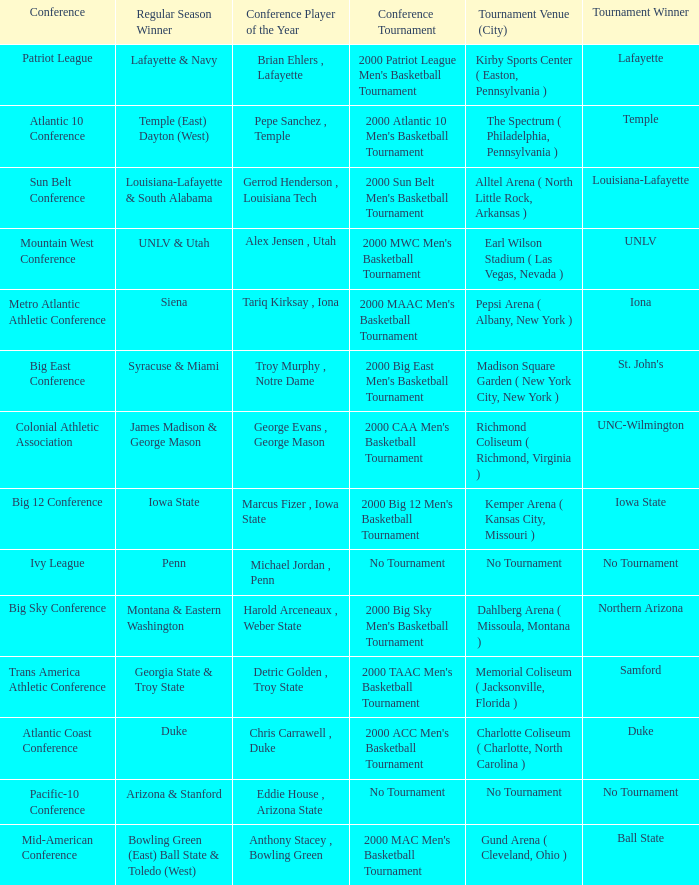How many players of the year are there in the Mountain West Conference? 1.0. 